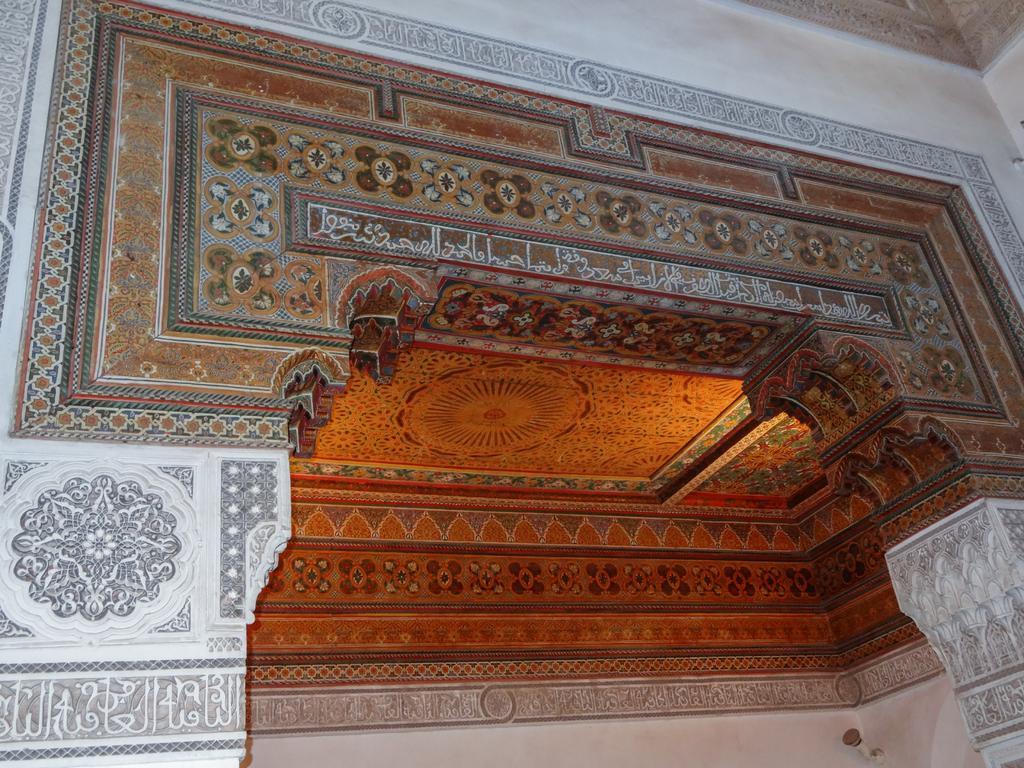How would you summarize this image in a sentence or two? In this image there is a building and also, on the wall there is some text which is in Urdu and there is a ceiling. 